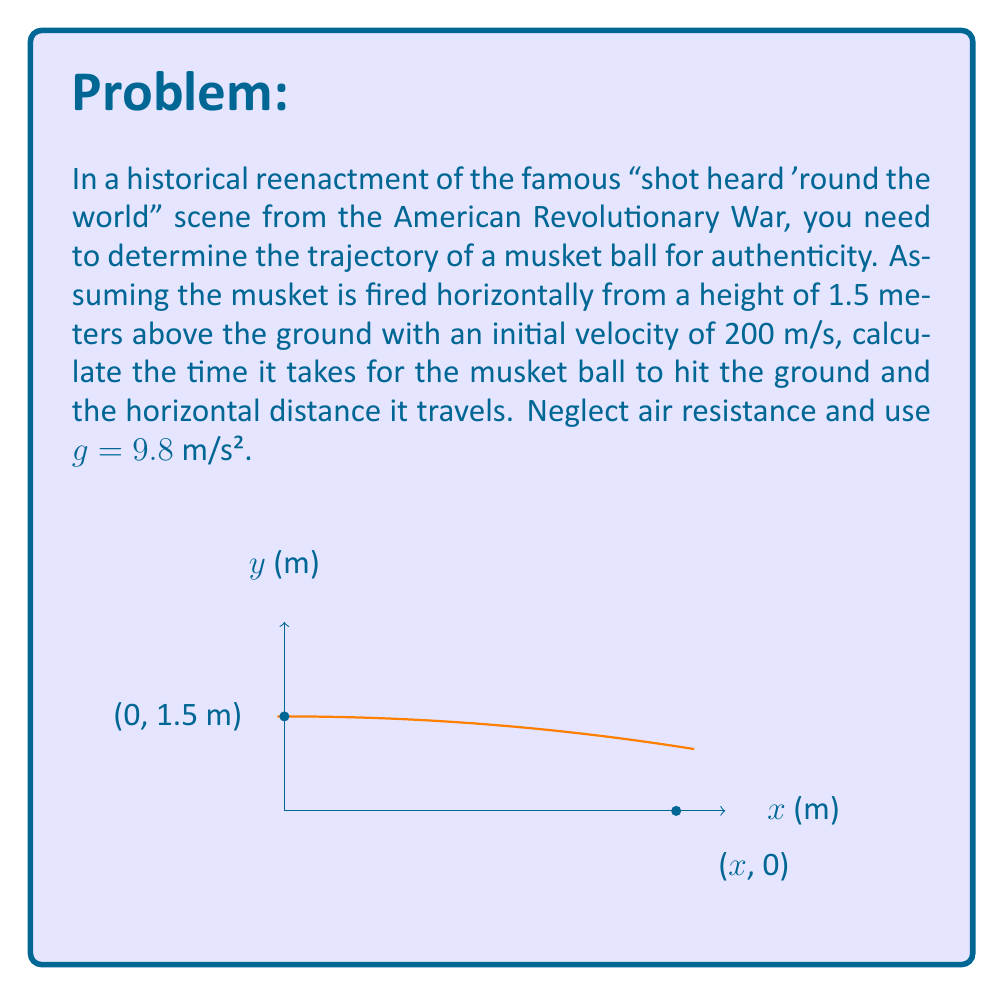Give your solution to this math problem. Let's approach this step-by-step using the second-order linear equations for projectile motion:

1) For vertical motion:
   $$y = y_0 + v_{0y}t - \frac{1}{2}gt^2$$
   Where $y_0 = 1.5$ m, $v_{0y} = 0$ m/s (horizontal firing), and $g = 9.8$ m/s².

2) To find the time to hit the ground, set $y = 0$:
   $$0 = 1.5 - \frac{1}{2}(9.8)t^2$$

3) Solve for $t$:
   $$\frac{1}{2}(9.8)t^2 = 1.5$$
   $$t^2 = \frac{2(1.5)}{9.8} = 0.3061$$
   $$t = \sqrt{0.3061} = 0.5533 \text{ seconds}$$

4) For horizontal motion:
   $$x = v_0t$$
   Where $v_0 = 200$ m/s (initial velocity)

5) Calculate the horizontal distance:
   $$x = 200 \cdot 0.5533 = 110.66 \text{ meters}$$
Answer: Time to hit ground: 0.5533 s; Horizontal distance: 110.66 m 